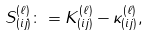<formula> <loc_0><loc_0><loc_500><loc_500>S _ { ( i j ) } ^ { ( \ell ) } \colon = K _ { ( i j ) } ^ { ( \ell ) } - \kappa _ { ( i j ) } ^ { ( \ell ) } ,</formula> 